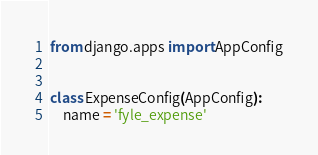Convert code to text. <code><loc_0><loc_0><loc_500><loc_500><_Python_>from django.apps import AppConfig


class ExpenseConfig(AppConfig):
    name = 'fyle_expense'
</code> 